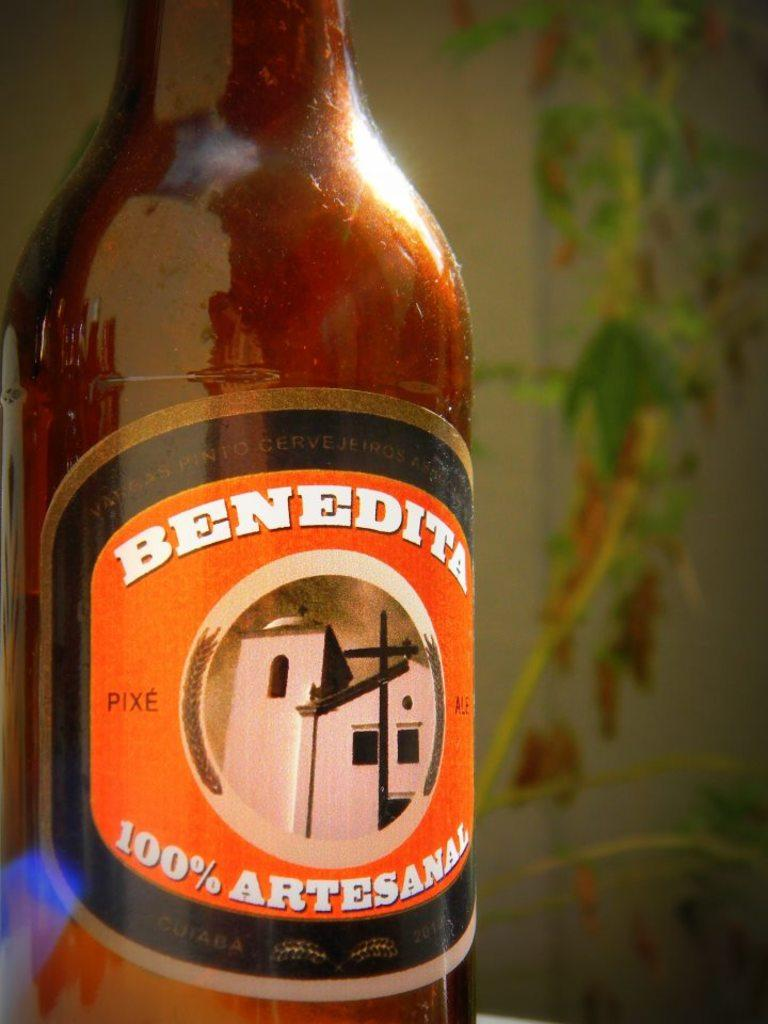What object can be seen in the image? There is a bottle in the image. What is unique about the bottle? The bottle has a striker attached to it. What type of bird is sitting on the vest in the image? There is no bird or vest present in the image; it only features a bottle with a striker attached to it. 